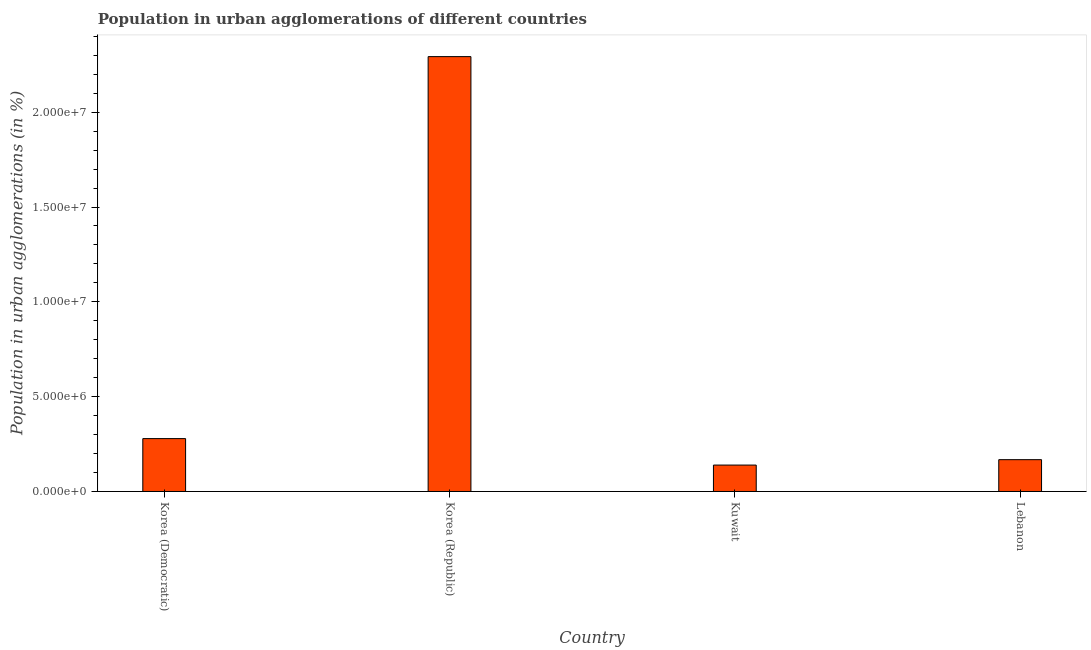Does the graph contain any zero values?
Keep it short and to the point. No. Does the graph contain grids?
Offer a terse response. No. What is the title of the graph?
Your response must be concise. Population in urban agglomerations of different countries. What is the label or title of the Y-axis?
Provide a short and direct response. Population in urban agglomerations (in %). What is the population in urban agglomerations in Korea (Republic)?
Ensure brevity in your answer.  2.29e+07. Across all countries, what is the maximum population in urban agglomerations?
Provide a short and direct response. 2.29e+07. Across all countries, what is the minimum population in urban agglomerations?
Keep it short and to the point. 1.39e+06. In which country was the population in urban agglomerations minimum?
Provide a short and direct response. Kuwait. What is the sum of the population in urban agglomerations?
Your response must be concise. 2.88e+07. What is the difference between the population in urban agglomerations in Korea (Democratic) and Korea (Republic)?
Provide a short and direct response. -2.01e+07. What is the average population in urban agglomerations per country?
Keep it short and to the point. 7.20e+06. What is the median population in urban agglomerations?
Offer a very short reply. 2.23e+06. In how many countries, is the population in urban agglomerations greater than 5000000 %?
Offer a terse response. 1. What is the ratio of the population in urban agglomerations in Korea (Democratic) to that in Kuwait?
Your response must be concise. 2. Is the population in urban agglomerations in Korea (Democratic) less than that in Korea (Republic)?
Make the answer very short. Yes. What is the difference between the highest and the second highest population in urban agglomerations?
Ensure brevity in your answer.  2.01e+07. What is the difference between the highest and the lowest population in urban agglomerations?
Keep it short and to the point. 2.15e+07. In how many countries, is the population in urban agglomerations greater than the average population in urban agglomerations taken over all countries?
Provide a succinct answer. 1. Are all the bars in the graph horizontal?
Offer a very short reply. No. How many countries are there in the graph?
Keep it short and to the point. 4. What is the difference between two consecutive major ticks on the Y-axis?
Provide a succinct answer. 5.00e+06. Are the values on the major ticks of Y-axis written in scientific E-notation?
Offer a very short reply. Yes. What is the Population in urban agglomerations (in %) of Korea (Democratic)?
Offer a very short reply. 2.79e+06. What is the Population in urban agglomerations (in %) in Korea (Republic)?
Provide a short and direct response. 2.29e+07. What is the Population in urban agglomerations (in %) of Kuwait?
Offer a terse response. 1.39e+06. What is the Population in urban agglomerations (in %) in Lebanon?
Offer a terse response. 1.68e+06. What is the difference between the Population in urban agglomerations (in %) in Korea (Democratic) and Korea (Republic)?
Provide a succinct answer. -2.01e+07. What is the difference between the Population in urban agglomerations (in %) in Korea (Democratic) and Kuwait?
Provide a succinct answer. 1.40e+06. What is the difference between the Population in urban agglomerations (in %) in Korea (Democratic) and Lebanon?
Offer a very short reply. 1.11e+06. What is the difference between the Population in urban agglomerations (in %) in Korea (Republic) and Kuwait?
Give a very brief answer. 2.15e+07. What is the difference between the Population in urban agglomerations (in %) in Korea (Republic) and Lebanon?
Provide a short and direct response. 2.13e+07. What is the difference between the Population in urban agglomerations (in %) in Kuwait and Lebanon?
Your answer should be very brief. -2.85e+05. What is the ratio of the Population in urban agglomerations (in %) in Korea (Democratic) to that in Korea (Republic)?
Provide a succinct answer. 0.12. What is the ratio of the Population in urban agglomerations (in %) in Korea (Democratic) to that in Kuwait?
Offer a very short reply. 2. What is the ratio of the Population in urban agglomerations (in %) in Korea (Democratic) to that in Lebanon?
Provide a succinct answer. 1.66. What is the ratio of the Population in urban agglomerations (in %) in Korea (Republic) to that in Kuwait?
Offer a very short reply. 16.47. What is the ratio of the Population in urban agglomerations (in %) in Korea (Republic) to that in Lebanon?
Give a very brief answer. 13.67. What is the ratio of the Population in urban agglomerations (in %) in Kuwait to that in Lebanon?
Your answer should be compact. 0.83. 